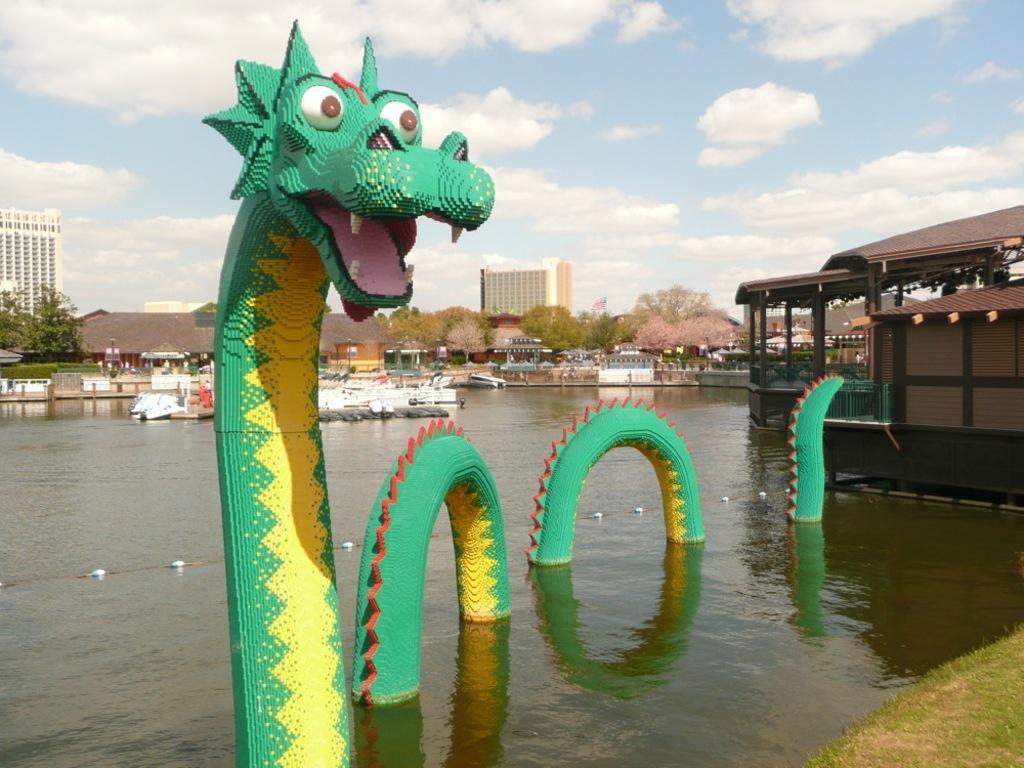In one or two sentences, can you explain what this image depicts? In the center of the image we can see buildings, trees, boats are there. On the right side of the image a house is there. In the center of the image we can see water, slides are there. At the top of the image clouds are present in the sky. At the bottom right corner grass is there. 